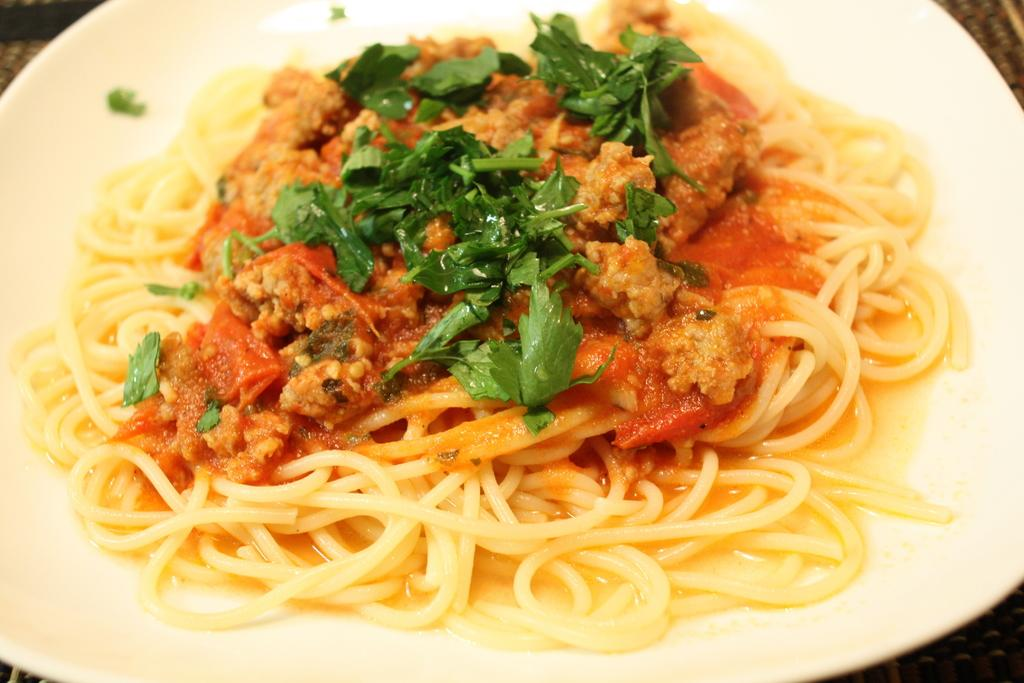What is present on a plate in the image? There is food in a plate in the image. How is the food on the plate decorated or garnished? The food is topped with coriander leaves. How many ladybugs can be seen crawling on the food in the image? There are no ladybugs present in the image; it only features food topped with coriander leaves. 